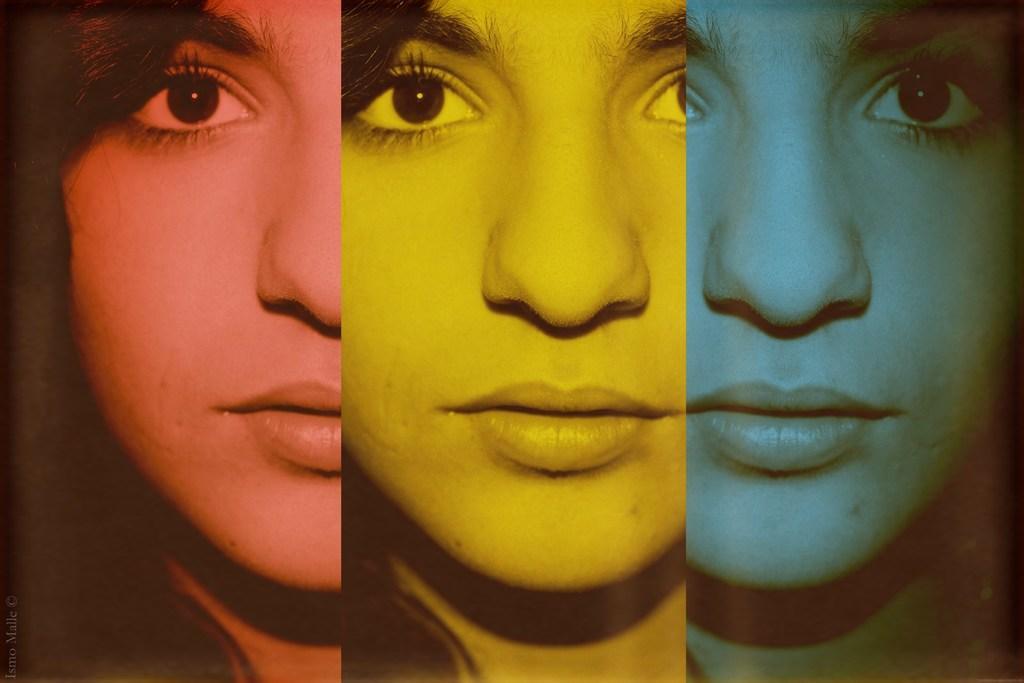In one or two sentences, can you explain what this image depicts? This is an edited image and we can see the eyes, eyebrows, noses and mouths of the persons. 